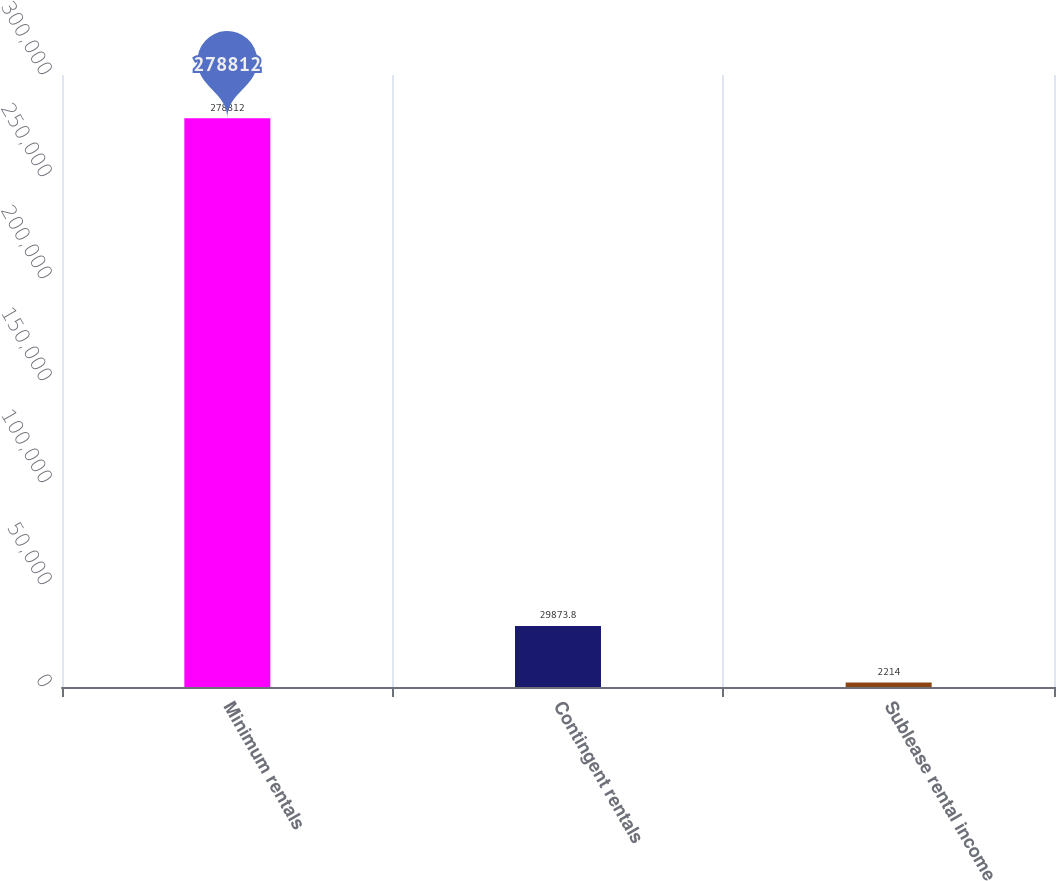<chart> <loc_0><loc_0><loc_500><loc_500><bar_chart><fcel>Minimum rentals<fcel>Contingent rentals<fcel>Sublease rental income<nl><fcel>278812<fcel>29873.8<fcel>2214<nl></chart> 